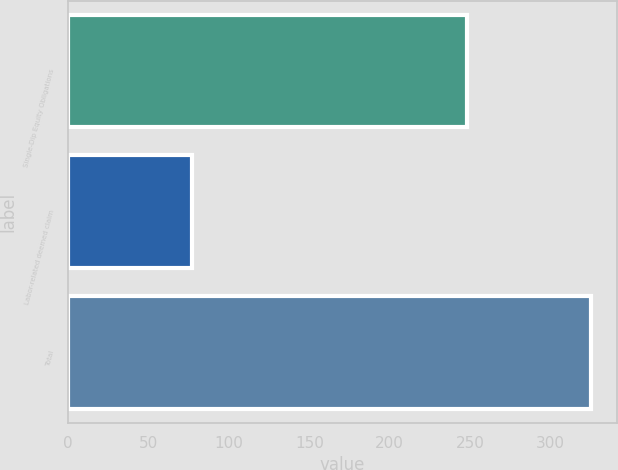<chart> <loc_0><loc_0><loc_500><loc_500><bar_chart><fcel>Single-Dip Equity Obligations<fcel>Labor-related deemed claim<fcel>Total<nl><fcel>248<fcel>77<fcel>325<nl></chart> 